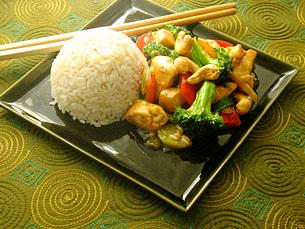What utensil will the food be eaten with?

Choices:
A) chopstick
B) knife
C) spoon
D) fork chopstick 